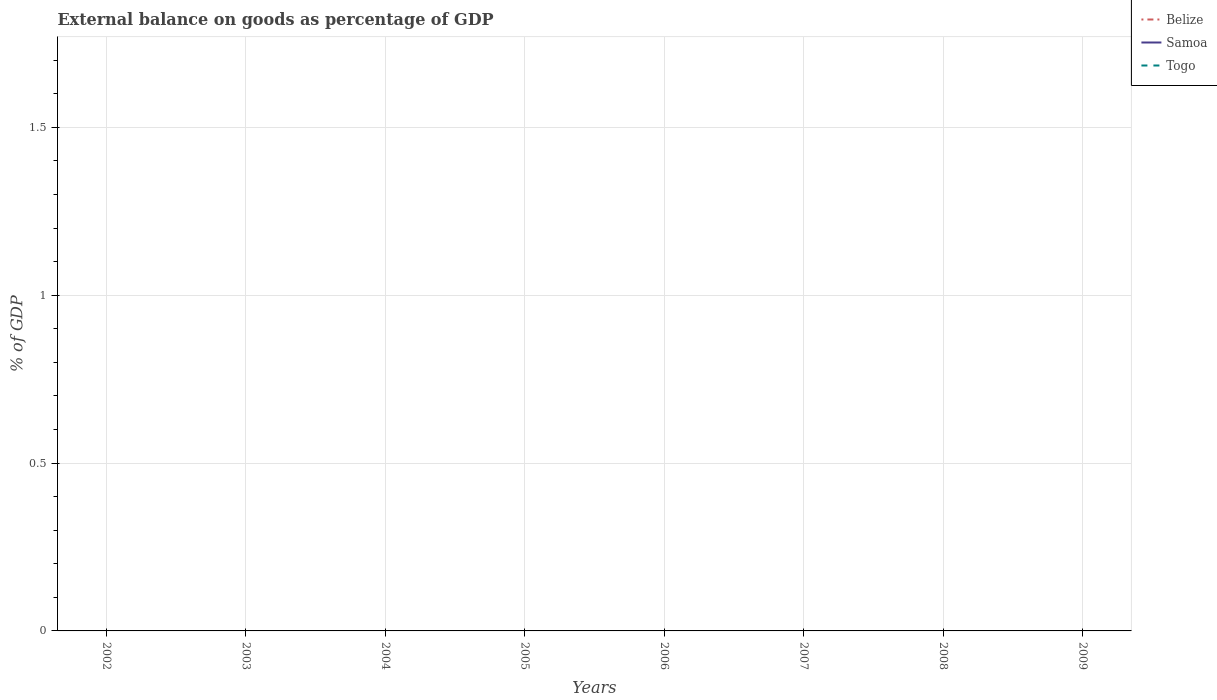Is the number of lines equal to the number of legend labels?
Your answer should be very brief. No. Across all years, what is the maximum external balance on goods as percentage of GDP in Samoa?
Offer a terse response. 0. What is the difference between the highest and the lowest external balance on goods as percentage of GDP in Samoa?
Provide a short and direct response. 0. Does the graph contain any zero values?
Your response must be concise. Yes. Where does the legend appear in the graph?
Ensure brevity in your answer.  Top right. How are the legend labels stacked?
Make the answer very short. Vertical. What is the title of the graph?
Offer a terse response. External balance on goods as percentage of GDP. Does "Turkey" appear as one of the legend labels in the graph?
Give a very brief answer. No. What is the label or title of the X-axis?
Keep it short and to the point. Years. What is the label or title of the Y-axis?
Provide a succinct answer. % of GDP. What is the % of GDP of Belize in 2003?
Your answer should be compact. 0. What is the % of GDP in Togo in 2003?
Make the answer very short. 0. What is the % of GDP of Belize in 2004?
Your answer should be compact. 0. What is the % of GDP in Belize in 2005?
Your answer should be compact. 0. What is the % of GDP of Samoa in 2005?
Your response must be concise. 0. What is the % of GDP of Samoa in 2006?
Your response must be concise. 0. What is the % of GDP in Togo in 2006?
Give a very brief answer. 0. What is the % of GDP in Samoa in 2007?
Keep it short and to the point. 0. What is the % of GDP in Togo in 2008?
Offer a terse response. 0. What is the % of GDP in Samoa in 2009?
Your answer should be compact. 0. What is the total % of GDP of Belize in the graph?
Your response must be concise. 0. What is the total % of GDP of Samoa in the graph?
Provide a short and direct response. 0. What is the average % of GDP in Belize per year?
Ensure brevity in your answer.  0. What is the average % of GDP of Samoa per year?
Your response must be concise. 0. 